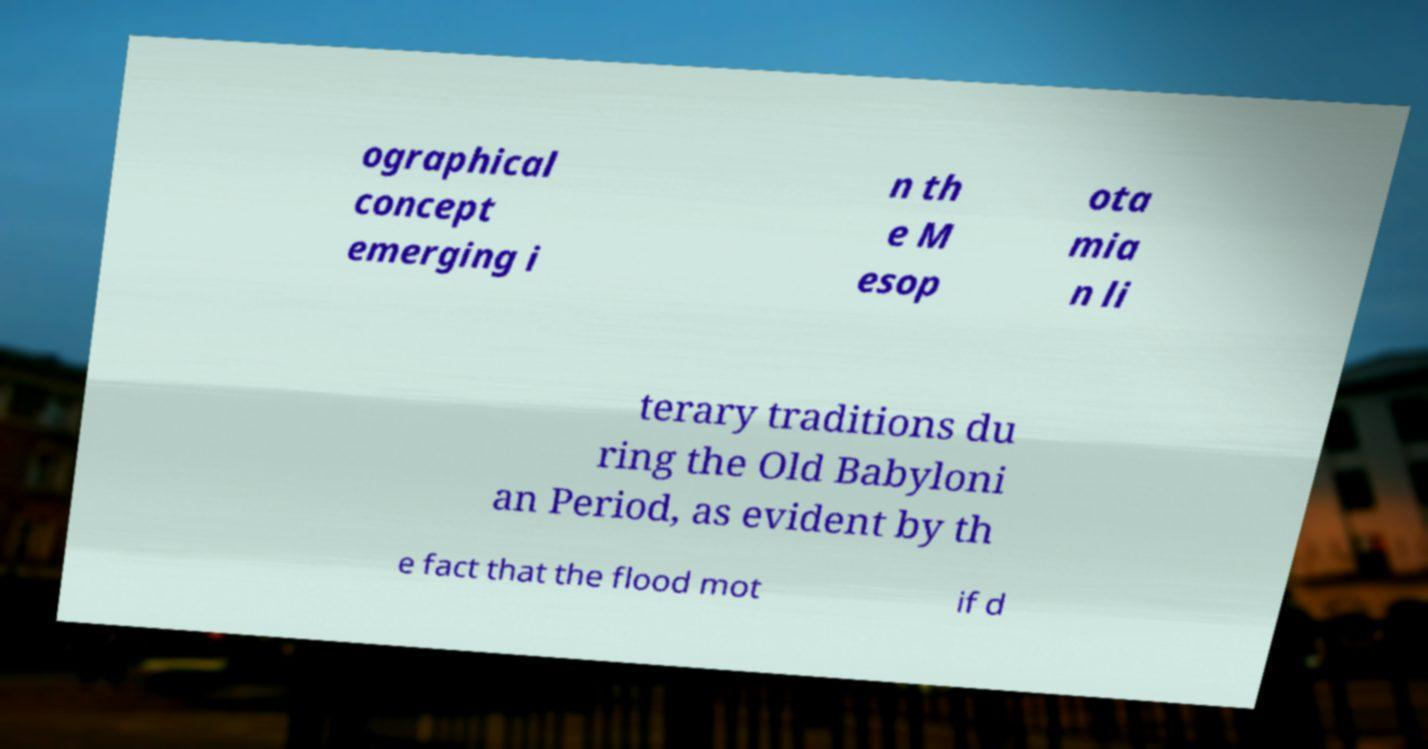What messages or text are displayed in this image? I need them in a readable, typed format. ographical concept emerging i n th e M esop ota mia n li terary traditions du ring the Old Babyloni an Period, as evident by th e fact that the flood mot if d 